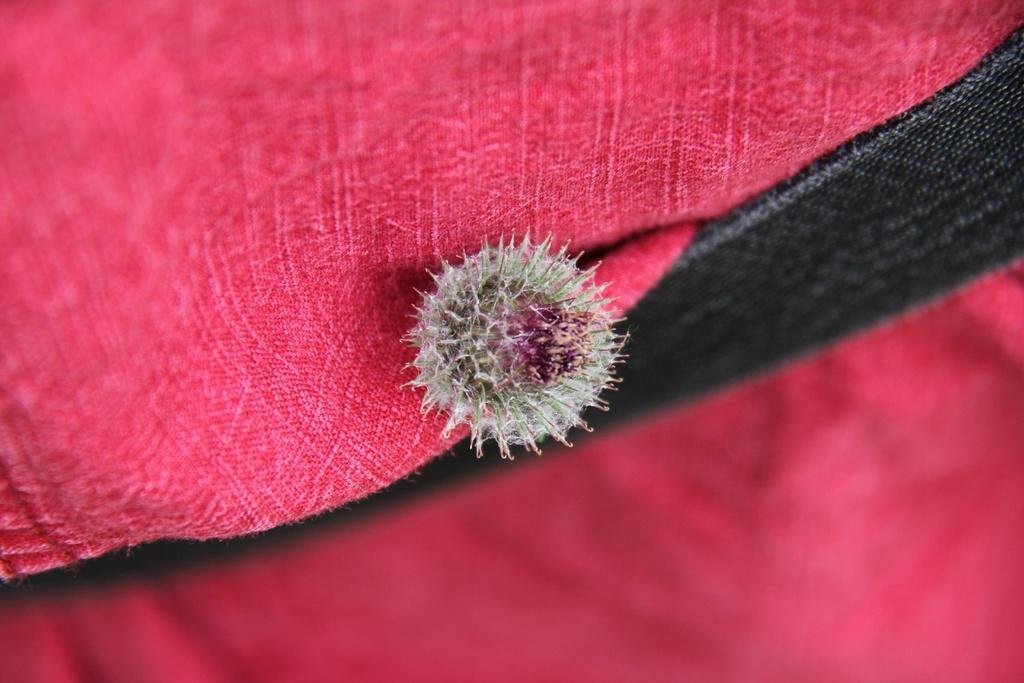Could you give a brief overview of what you see in this image? In this image, in the middle, we can see a seed. In the background there is red color and black color. 